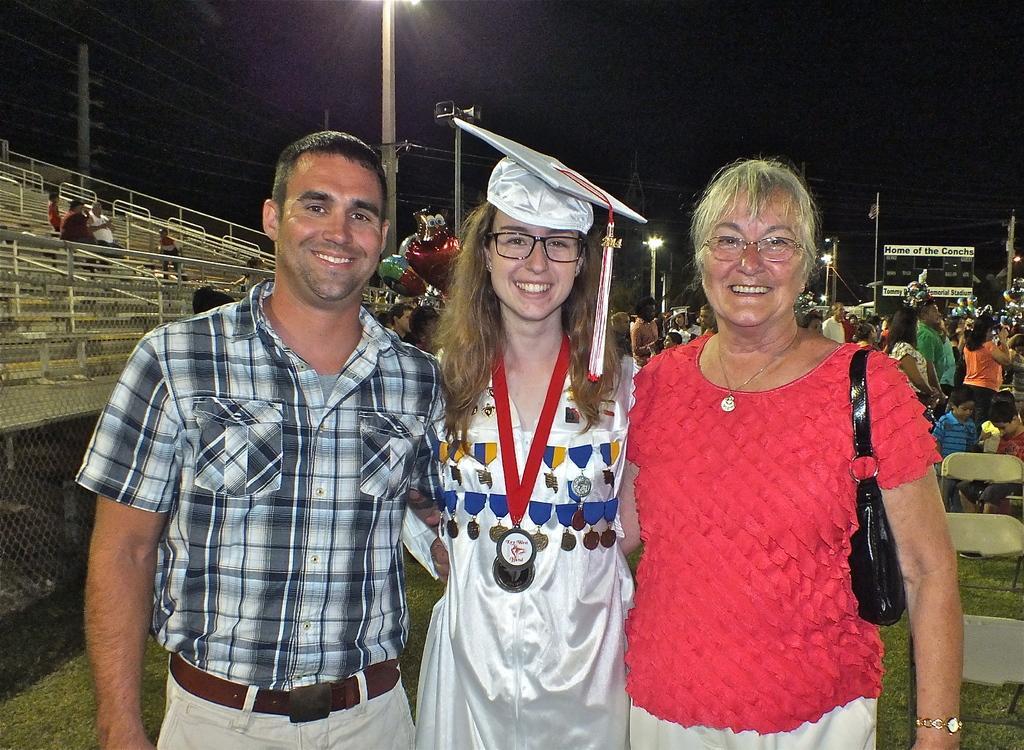In one or two sentences, can you explain what this image depicts? There are three persons standing in the middle of this image. There is a fencing on the left side of this image and there is a seating area at the top left side of this image. There are some persons standing in the background. There are some chairs on the right side of this image. There is a sky at the top of this image. 